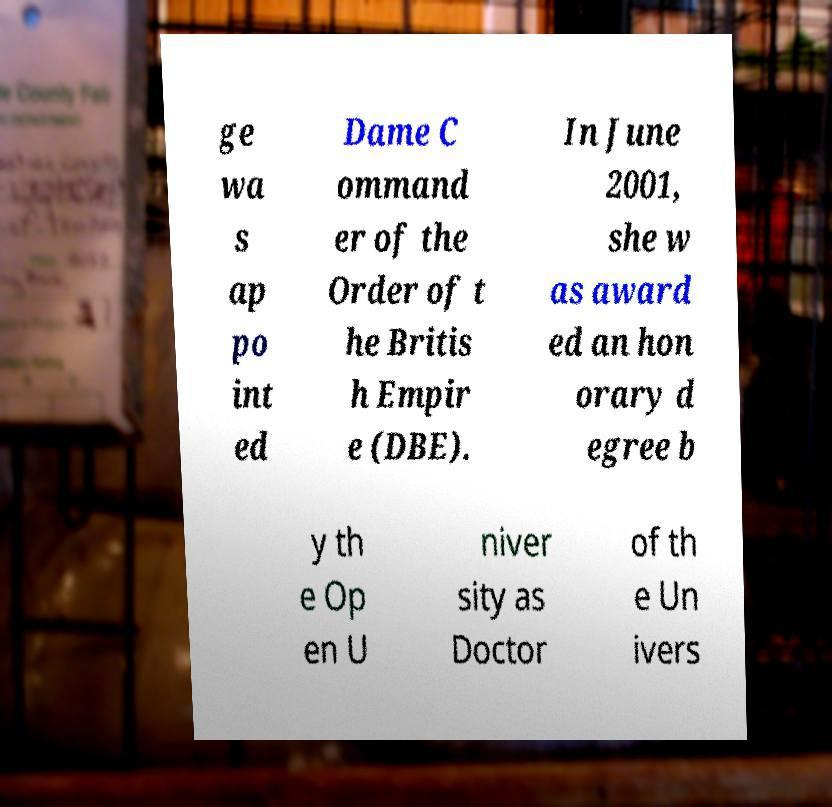Please read and relay the text visible in this image. What does it say? ge wa s ap po int ed Dame C ommand er of the Order of t he Britis h Empir e (DBE). In June 2001, she w as award ed an hon orary d egree b y th e Op en U niver sity as Doctor of th e Un ivers 